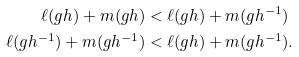<formula> <loc_0><loc_0><loc_500><loc_500>\ell ( g h ) + m ( g h ) & < \ell ( g h ) + m ( g h ^ { - 1 } ) \\ \ell ( g h ^ { - 1 } ) + m ( g h ^ { - 1 } ) & < \ell ( g h ) + m ( g h ^ { - 1 } ) .</formula> 